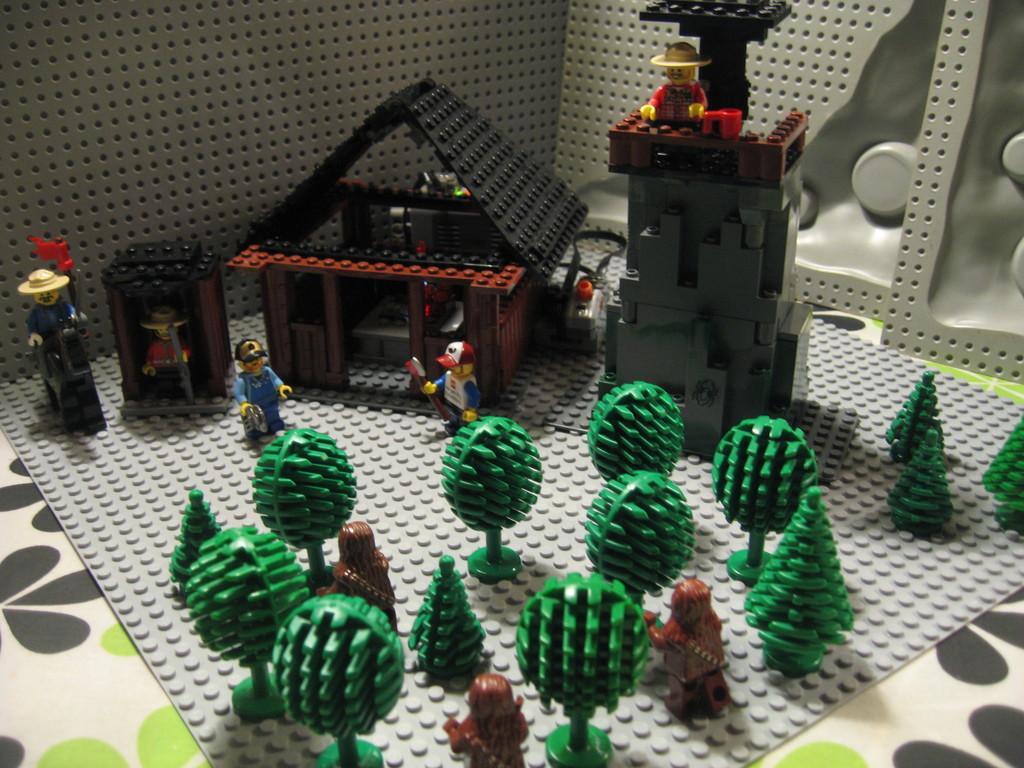Describe this image in one or two sentences. In the image on the surface there is a model. In the model there are trees,man, houses with roofs and walls and there are machines. And there is a grey color background. 